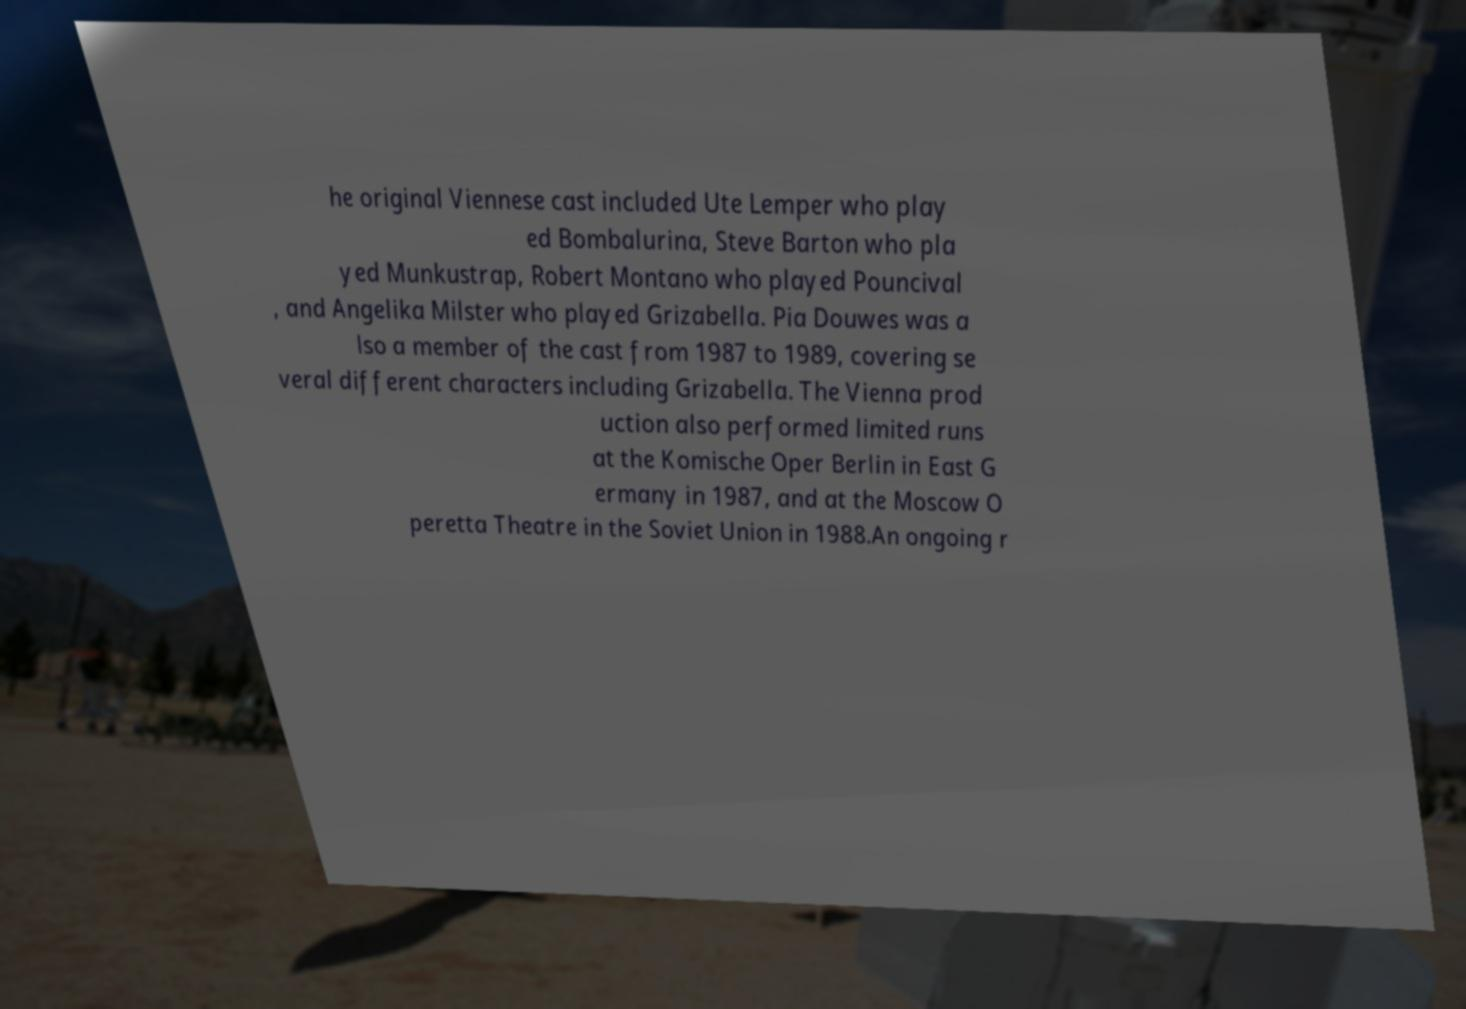I need the written content from this picture converted into text. Can you do that? he original Viennese cast included Ute Lemper who play ed Bombalurina, Steve Barton who pla yed Munkustrap, Robert Montano who played Pouncival , and Angelika Milster who played Grizabella. Pia Douwes was a lso a member of the cast from 1987 to 1989, covering se veral different characters including Grizabella. The Vienna prod uction also performed limited runs at the Komische Oper Berlin in East G ermany in 1987, and at the Moscow O peretta Theatre in the Soviet Union in 1988.An ongoing r 